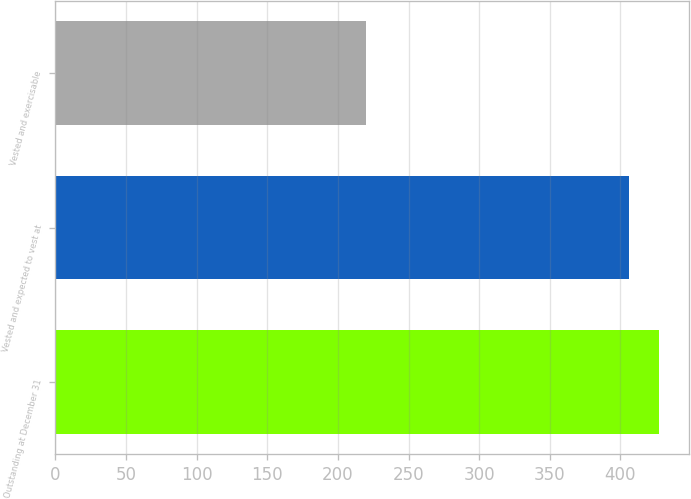Convert chart. <chart><loc_0><loc_0><loc_500><loc_500><bar_chart><fcel>Outstanding at December 31<fcel>Vested and expected to vest at<fcel>Vested and exercisable<nl><fcel>427<fcel>406<fcel>220<nl></chart> 